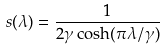<formula> <loc_0><loc_0><loc_500><loc_500>s ( \lambda ) = \frac { 1 } { 2 \gamma \cosh ( \pi \lambda / \gamma ) }</formula> 